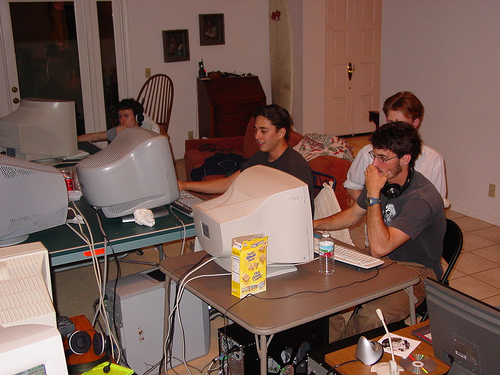What are the people doing in this image? The individuals appear to be engaged in using computers, likely for tasks that could range from gaming, programming, or working on group projects. The setting suggests an informal, tech-focused gathering, possibly among friends or team members. 